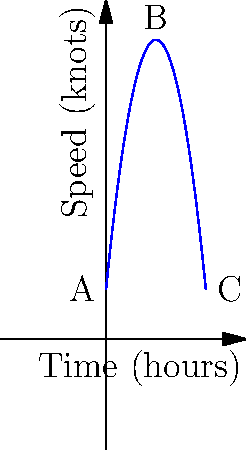The quadratic function $f(t) = -0.5t^2 + 10t + 10$ represents the Titanic's speed in knots over time t in hours during its maiden voyage. At what time did the Titanic reach its maximum speed, and what was that speed? To find the maximum speed and when it occurred, we need to follow these steps:

1) The maximum point of a quadratic function occurs at the vertex of the parabola.

2) For a quadratic function in the form $f(t) = at^2 + bt + c$, the t-coordinate of the vertex is given by $t = -\frac{b}{2a}$.

3) In this case, $a = -0.5$, $b = 10$, and $c = 10$.

4) Substituting these values:
   $t = -\frac{10}{2(-0.5)} = -\frac{10}{-1} = 10$ hours

5) To find the maximum speed, we substitute t = 10 into the original function:
   $f(10) = -0.5(10)^2 + 10(10) + 10$
   $= -0.5(100) + 100 + 10$
   $= -50 + 100 + 10$
   $= 60$ knots

Therefore, the Titanic reached its maximum speed of 60 knots after 10 hours of its voyage.
Answer: 10 hours; 60 knots 